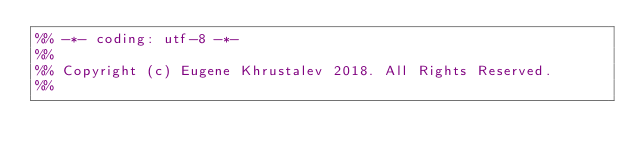<code> <loc_0><loc_0><loc_500><loc_500><_Erlang_>%% -*- coding: utf-8 -*-
%%
%% Copyright (c) Eugene Khrustalev 2018. All Rights Reserved.
%%</code> 